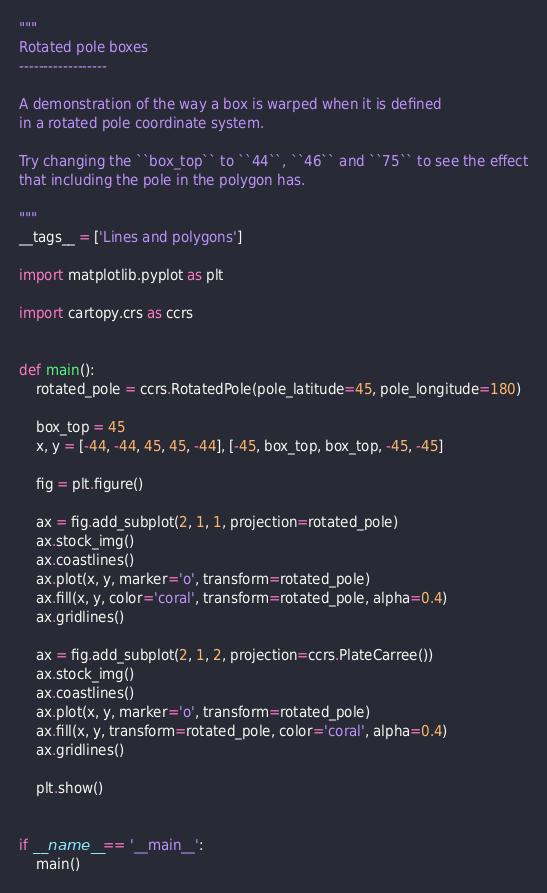Convert code to text. <code><loc_0><loc_0><loc_500><loc_500><_Python_>"""
Rotated pole boxes
------------------

A demonstration of the way a box is warped when it is defined
in a rotated pole coordinate system.

Try changing the ``box_top`` to ``44``, ``46`` and ``75`` to see the effect
that including the pole in the polygon has.

"""
__tags__ = ['Lines and polygons']

import matplotlib.pyplot as plt

import cartopy.crs as ccrs


def main():
    rotated_pole = ccrs.RotatedPole(pole_latitude=45, pole_longitude=180)

    box_top = 45
    x, y = [-44, -44, 45, 45, -44], [-45, box_top, box_top, -45, -45]

    fig = plt.figure()

    ax = fig.add_subplot(2, 1, 1, projection=rotated_pole)
    ax.stock_img()
    ax.coastlines()
    ax.plot(x, y, marker='o', transform=rotated_pole)
    ax.fill(x, y, color='coral', transform=rotated_pole, alpha=0.4)
    ax.gridlines()

    ax = fig.add_subplot(2, 1, 2, projection=ccrs.PlateCarree())
    ax.stock_img()
    ax.coastlines()
    ax.plot(x, y, marker='o', transform=rotated_pole)
    ax.fill(x, y, transform=rotated_pole, color='coral', alpha=0.4)
    ax.gridlines()

    plt.show()


if __name__ == '__main__':
    main()
</code> 